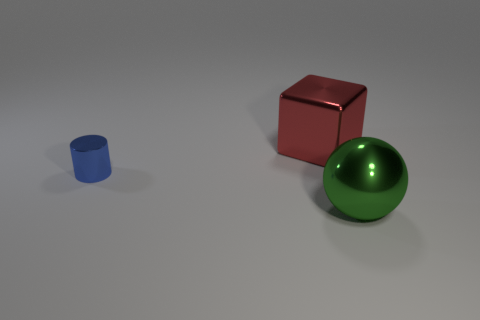Are there any other things that are the same size as the blue cylinder?
Offer a very short reply. No. What number of other things are there of the same color as the small metallic cylinder?
Give a very brief answer. 0. What number of small cyan metal cylinders are there?
Offer a very short reply. 0. How many metallic objects are both behind the blue thing and to the left of the big cube?
Offer a terse response. 0. What material is the tiny thing?
Provide a succinct answer. Metal. Is there a large blue matte cube?
Provide a short and direct response. No. There is a metal object in front of the blue thing; what color is it?
Ensure brevity in your answer.  Green. What number of big metal objects are in front of the large metallic object that is on the left side of the big object that is to the right of the red shiny thing?
Make the answer very short. 1. There is a object that is both left of the big green metal object and in front of the metallic cube; what material is it?
Keep it short and to the point. Metal. Is the red cube made of the same material as the object to the right of the big shiny block?
Provide a succinct answer. Yes. 